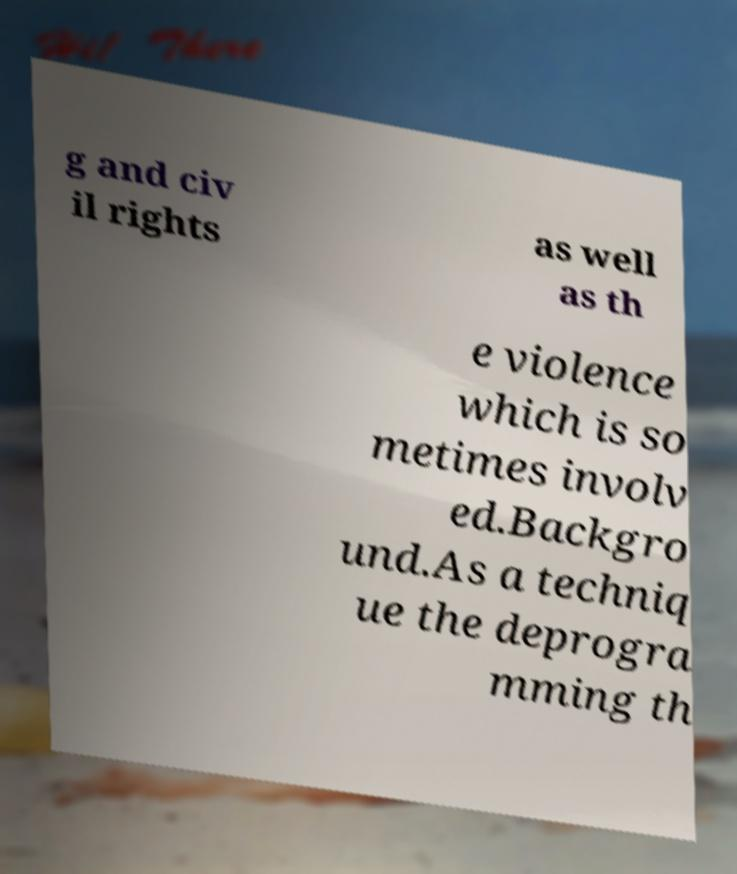Could you extract and type out the text from this image? g and civ il rights as well as th e violence which is so metimes involv ed.Backgro und.As a techniq ue the deprogra mming th 